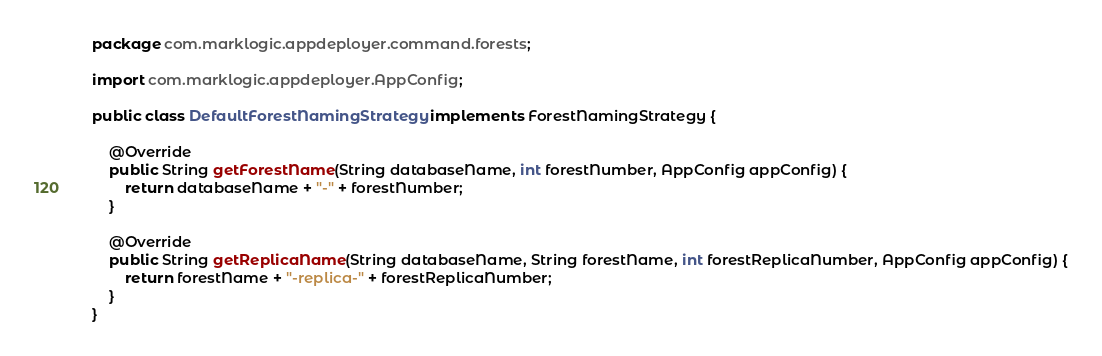Convert code to text. <code><loc_0><loc_0><loc_500><loc_500><_Java_>package com.marklogic.appdeployer.command.forests;

import com.marklogic.appdeployer.AppConfig;

public class DefaultForestNamingStrategy implements ForestNamingStrategy {

	@Override
	public String getForestName(String databaseName, int forestNumber, AppConfig appConfig) {
		return databaseName + "-" + forestNumber;
	}

	@Override
	public String getReplicaName(String databaseName, String forestName, int forestReplicaNumber, AppConfig appConfig) {
		return forestName + "-replica-" + forestReplicaNumber;
	}
}
</code> 